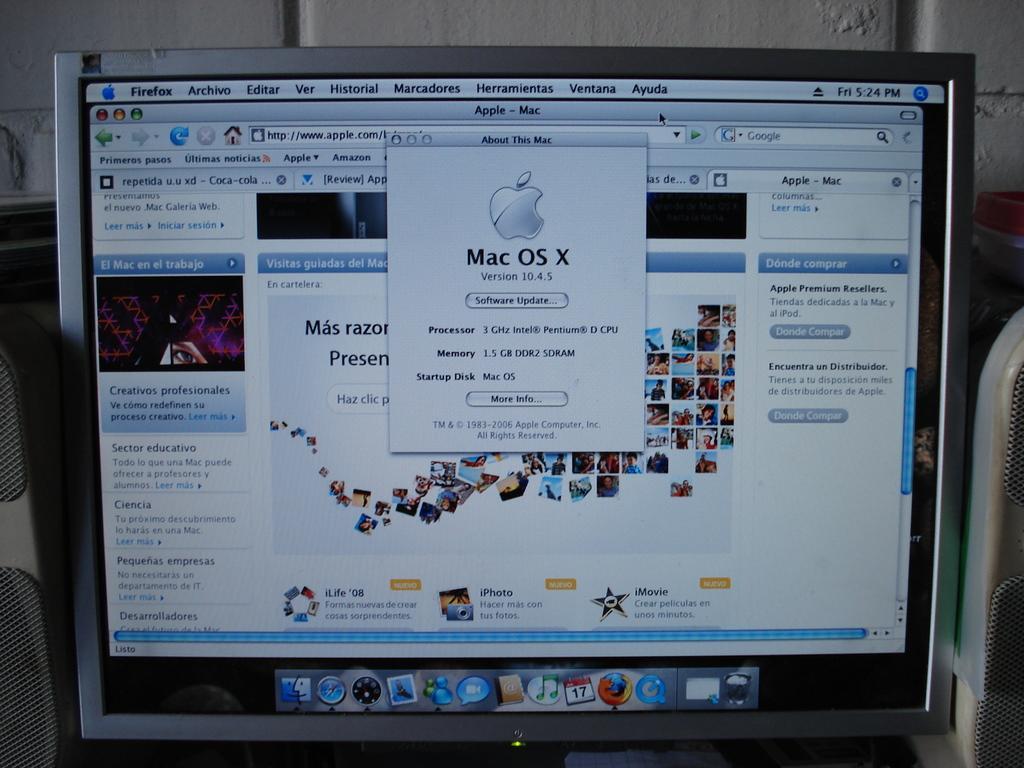In one or two sentences, can you explain what this image depicts? This image is taken indoors. In this image there is a monitor and speaker boxes. On the screen there a few pictures and there is a text on it. 